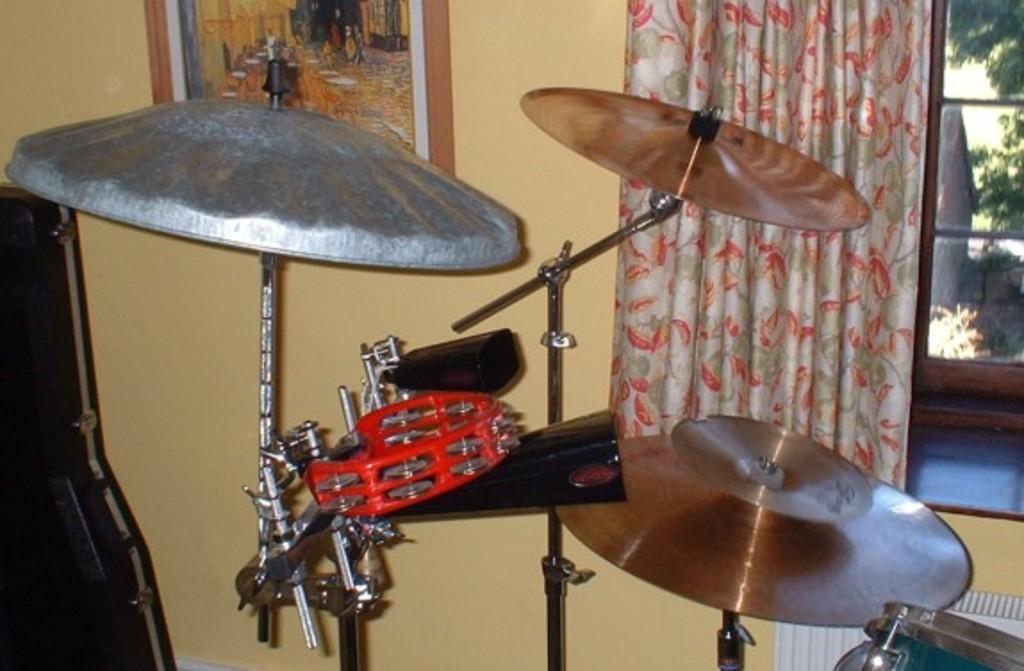In one or two sentences, can you explain what this image depicts? This is an inside view. Here I can see some musical instruments. On the right side there is a curtain to the window. At the top of the image there is a frame attached to the wall. Through the window we can see the outside view. In the outside there are few plants. 